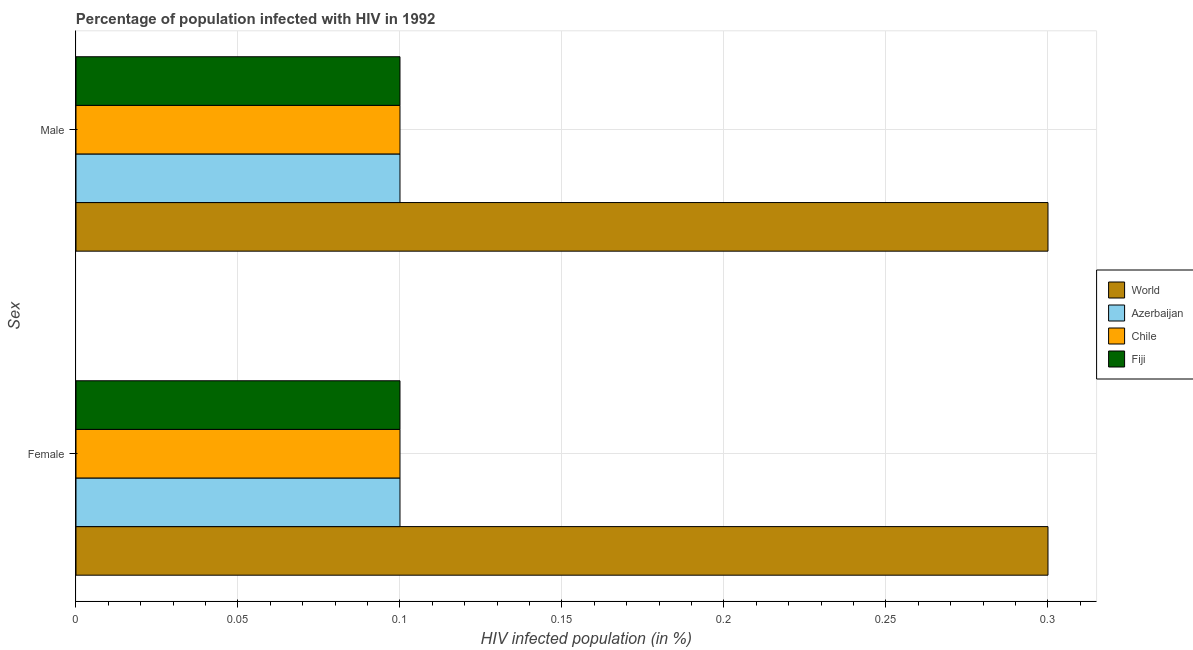How many groups of bars are there?
Your response must be concise. 2. How many bars are there on the 1st tick from the top?
Provide a short and direct response. 4. How many bars are there on the 2nd tick from the bottom?
Your answer should be compact. 4. What is the label of the 2nd group of bars from the top?
Offer a very short reply. Female. Across all countries, what is the maximum percentage of males who are infected with hiv?
Offer a very short reply. 0.3. Across all countries, what is the minimum percentage of males who are infected with hiv?
Offer a very short reply. 0.1. In which country was the percentage of males who are infected with hiv minimum?
Make the answer very short. Azerbaijan. What is the total percentage of females who are infected with hiv in the graph?
Your answer should be very brief. 0.6. What is the difference between the percentage of males who are infected with hiv in World and that in Chile?
Offer a terse response. 0.2. What is the difference between the percentage of males who are infected with hiv in World and the percentage of females who are infected with hiv in Chile?
Ensure brevity in your answer.  0.2. What is the average percentage of females who are infected with hiv per country?
Your answer should be compact. 0.15. What is the difference between the percentage of males who are infected with hiv and percentage of females who are infected with hiv in Chile?
Offer a very short reply. 0. What is the ratio of the percentage of females who are infected with hiv in Azerbaijan to that in World?
Keep it short and to the point. 0.33. What does the 1st bar from the top in Female represents?
Provide a short and direct response. Fiji. What does the 3rd bar from the bottom in Male represents?
Provide a succinct answer. Chile. Are all the bars in the graph horizontal?
Your answer should be very brief. Yes. Are the values on the major ticks of X-axis written in scientific E-notation?
Provide a succinct answer. No. Does the graph contain any zero values?
Ensure brevity in your answer.  No. Does the graph contain grids?
Provide a succinct answer. Yes. How are the legend labels stacked?
Provide a succinct answer. Vertical. What is the title of the graph?
Make the answer very short. Percentage of population infected with HIV in 1992. What is the label or title of the X-axis?
Offer a very short reply. HIV infected population (in %). What is the label or title of the Y-axis?
Offer a terse response. Sex. What is the HIV infected population (in %) of World in Female?
Ensure brevity in your answer.  0.3. What is the HIV infected population (in %) of Azerbaijan in Female?
Your answer should be very brief. 0.1. What is the HIV infected population (in %) in World in Male?
Your answer should be very brief. 0.3. What is the HIV infected population (in %) in Chile in Male?
Provide a short and direct response. 0.1. What is the HIV infected population (in %) of Fiji in Male?
Provide a succinct answer. 0.1. Across all Sex, what is the maximum HIV infected population (in %) in World?
Provide a succinct answer. 0.3. Across all Sex, what is the maximum HIV infected population (in %) of Azerbaijan?
Provide a short and direct response. 0.1. Across all Sex, what is the maximum HIV infected population (in %) in Chile?
Provide a short and direct response. 0.1. Across all Sex, what is the minimum HIV infected population (in %) in World?
Give a very brief answer. 0.3. What is the total HIV infected population (in %) in World in the graph?
Offer a very short reply. 0.6. What is the total HIV infected population (in %) of Fiji in the graph?
Make the answer very short. 0.2. What is the difference between the HIV infected population (in %) of Azerbaijan in Female and that in Male?
Your answer should be compact. 0. What is the difference between the HIV infected population (in %) in Fiji in Female and that in Male?
Provide a succinct answer. 0. What is the difference between the HIV infected population (in %) in World in Female and the HIV infected population (in %) in Fiji in Male?
Offer a very short reply. 0.2. What is the difference between the HIV infected population (in %) in Azerbaijan in Female and the HIV infected population (in %) in Fiji in Male?
Ensure brevity in your answer.  0. What is the average HIV infected population (in %) in World per Sex?
Offer a terse response. 0.3. What is the average HIV infected population (in %) in Chile per Sex?
Your response must be concise. 0.1. What is the difference between the HIV infected population (in %) in World and HIV infected population (in %) in Chile in Female?
Offer a terse response. 0.2. What is the difference between the HIV infected population (in %) of Azerbaijan and HIV infected population (in %) of Fiji in Female?
Ensure brevity in your answer.  0. What is the difference between the HIV infected population (in %) in World and HIV infected population (in %) in Azerbaijan in Male?
Ensure brevity in your answer.  0.2. What is the difference between the HIV infected population (in %) of World and HIV infected population (in %) of Chile in Male?
Offer a very short reply. 0.2. What is the difference between the HIV infected population (in %) in Azerbaijan and HIV infected population (in %) in Chile in Male?
Make the answer very short. 0. What is the difference between the HIV infected population (in %) in Azerbaijan and HIV infected population (in %) in Fiji in Male?
Give a very brief answer. 0. What is the ratio of the HIV infected population (in %) in Fiji in Female to that in Male?
Your answer should be compact. 1. What is the difference between the highest and the second highest HIV infected population (in %) in Azerbaijan?
Offer a terse response. 0. What is the difference between the highest and the second highest HIV infected population (in %) in Chile?
Offer a terse response. 0. What is the difference between the highest and the second highest HIV infected population (in %) of Fiji?
Give a very brief answer. 0. What is the difference between the highest and the lowest HIV infected population (in %) in World?
Give a very brief answer. 0. What is the difference between the highest and the lowest HIV infected population (in %) of Azerbaijan?
Keep it short and to the point. 0. What is the difference between the highest and the lowest HIV infected population (in %) of Chile?
Ensure brevity in your answer.  0. What is the difference between the highest and the lowest HIV infected population (in %) of Fiji?
Your answer should be very brief. 0. 